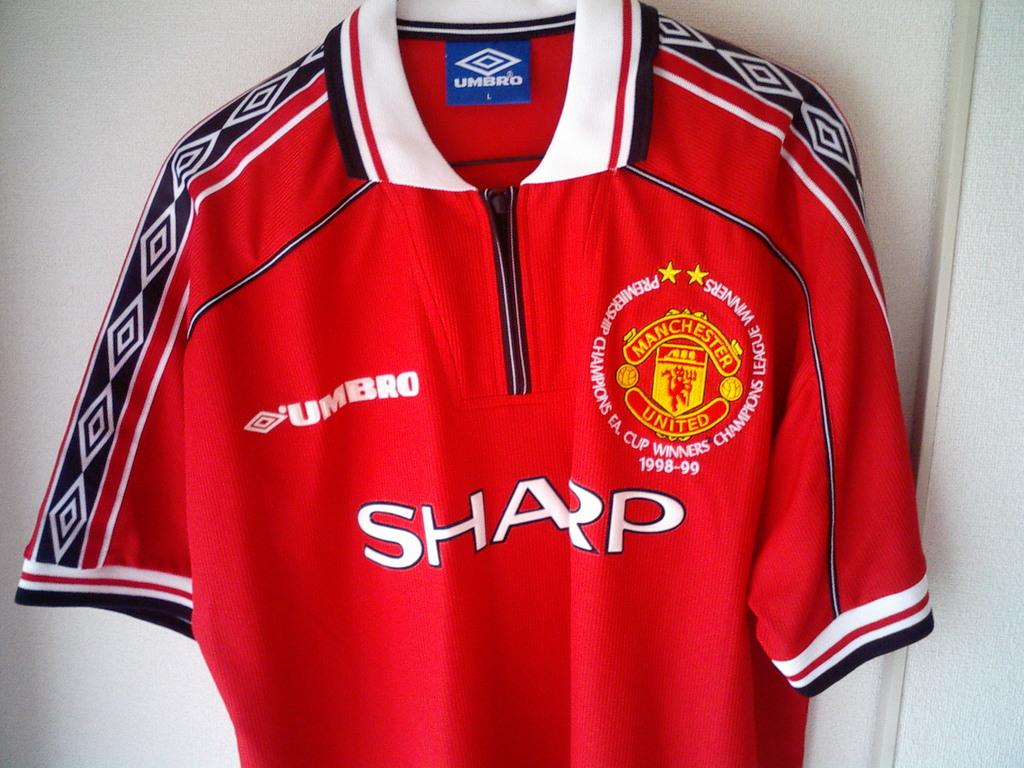<image>
Offer a succinct explanation of the picture presented. A red Manchester United shirt hangs against a white wall. 